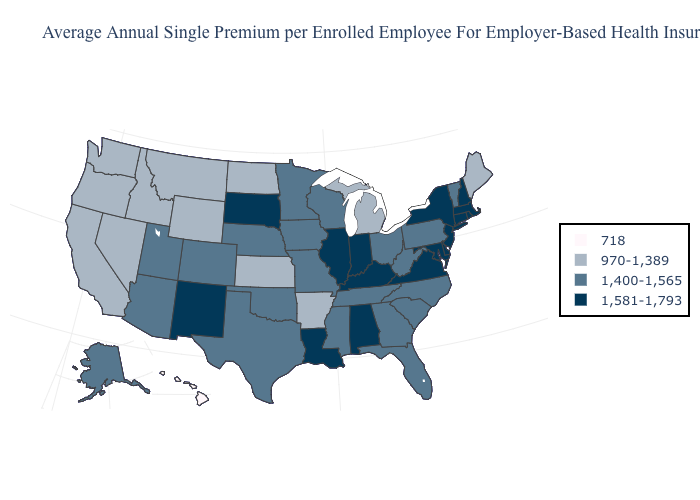What is the value of Ohio?
Be succinct. 1,400-1,565. Does the first symbol in the legend represent the smallest category?
Quick response, please. Yes. Among the states that border Kansas , which have the highest value?
Short answer required. Colorado, Missouri, Nebraska, Oklahoma. What is the highest value in the Northeast ?
Keep it brief. 1,581-1,793. Does Rhode Island have the lowest value in the USA?
Be succinct. No. Which states have the highest value in the USA?
Concise answer only. Alabama, Connecticut, Delaware, Illinois, Indiana, Kentucky, Louisiana, Maryland, Massachusetts, New Hampshire, New Jersey, New Mexico, New York, Rhode Island, South Dakota, Virginia. Which states have the lowest value in the USA?
Answer briefly. Hawaii. What is the value of New Jersey?
Give a very brief answer. 1,581-1,793. Does Virginia have a higher value than Nebraska?
Answer briefly. Yes. Does the map have missing data?
Write a very short answer. No. Name the states that have a value in the range 718?
Quick response, please. Hawaii. Which states hav the highest value in the South?
Write a very short answer. Alabama, Delaware, Kentucky, Louisiana, Maryland, Virginia. What is the value of Washington?
Concise answer only. 970-1,389. What is the lowest value in the South?
Write a very short answer. 970-1,389. How many symbols are there in the legend?
Short answer required. 4. 